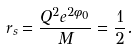Convert formula to latex. <formula><loc_0><loc_0><loc_500><loc_500>r _ { s } = \frac { Q ^ { 2 } e ^ { 2 \phi _ { 0 } } } { M } = \frac { 1 } { 2 } .</formula> 